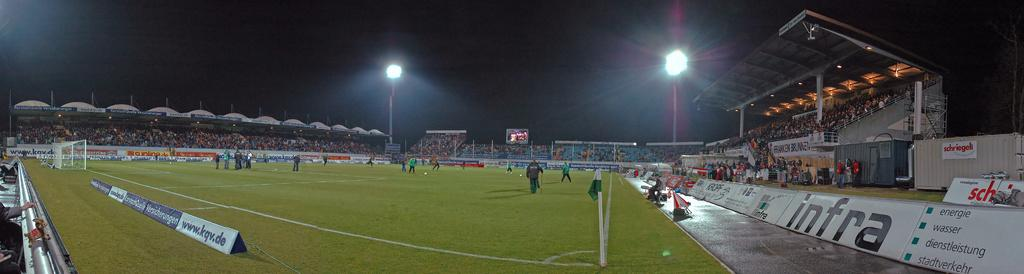<image>
Provide a brief description of the given image. A stadium with an Infra poster, full of people, and some player wearing  green pants. 